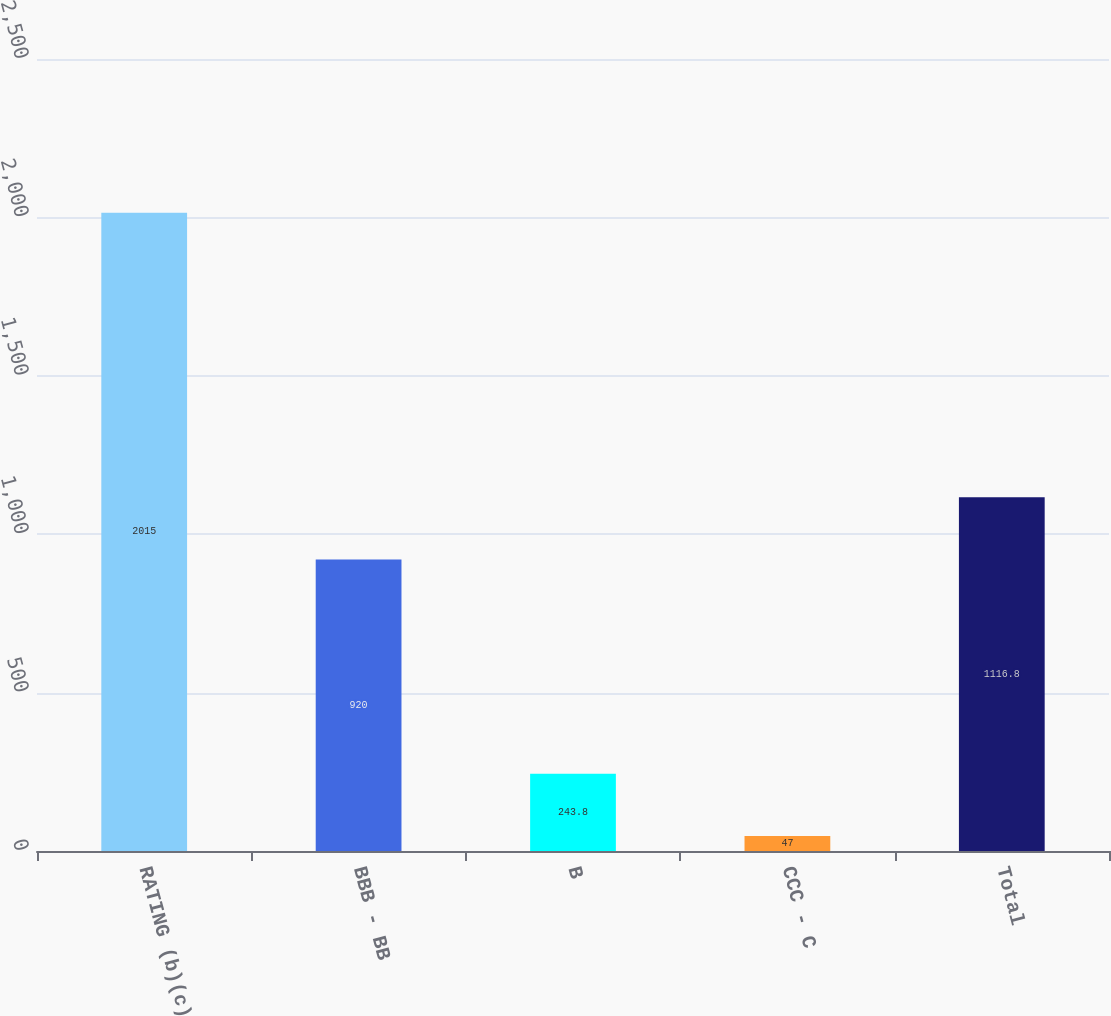<chart> <loc_0><loc_0><loc_500><loc_500><bar_chart><fcel>RATING (b)(c)<fcel>BBB - BB<fcel>B<fcel>CCC - C<fcel>Total<nl><fcel>2015<fcel>920<fcel>243.8<fcel>47<fcel>1116.8<nl></chart> 